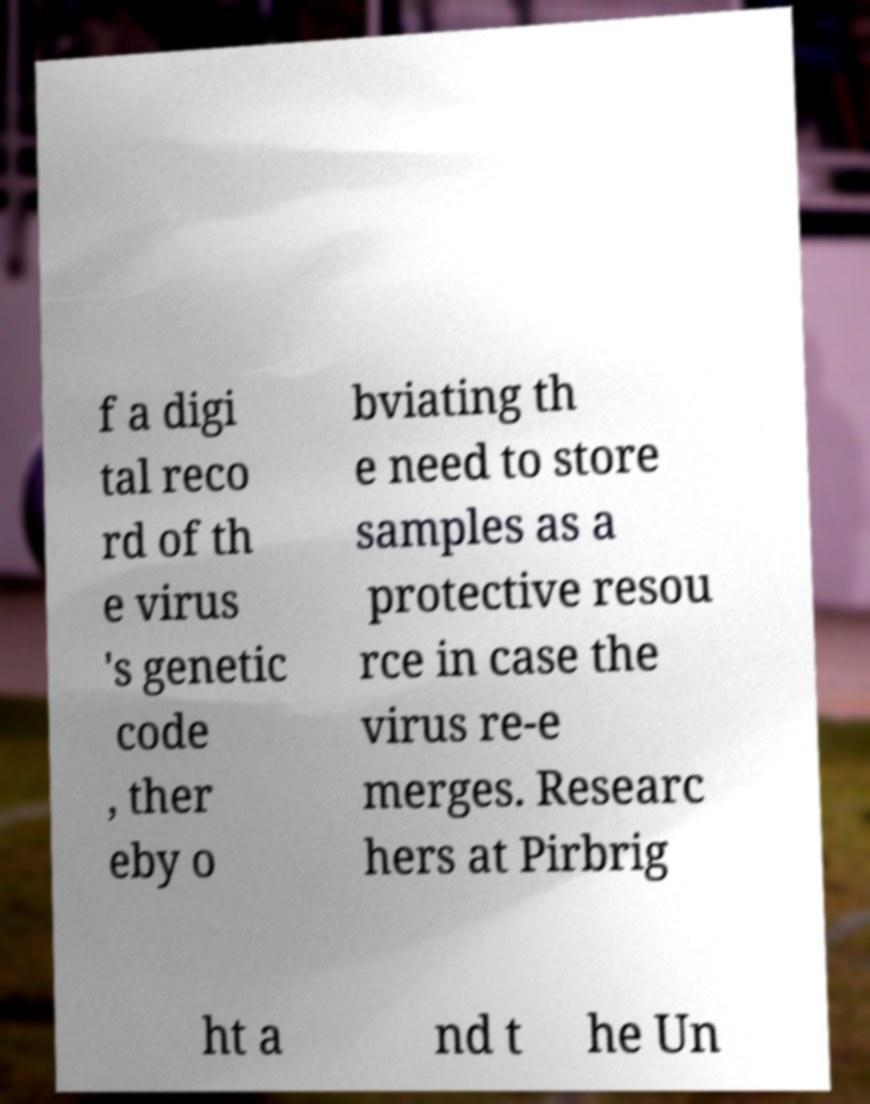Could you assist in decoding the text presented in this image and type it out clearly? f a digi tal reco rd of th e virus 's genetic code , ther eby o bviating th e need to store samples as a protective resou rce in case the virus re-e merges. Researc hers at Pirbrig ht a nd t he Un 